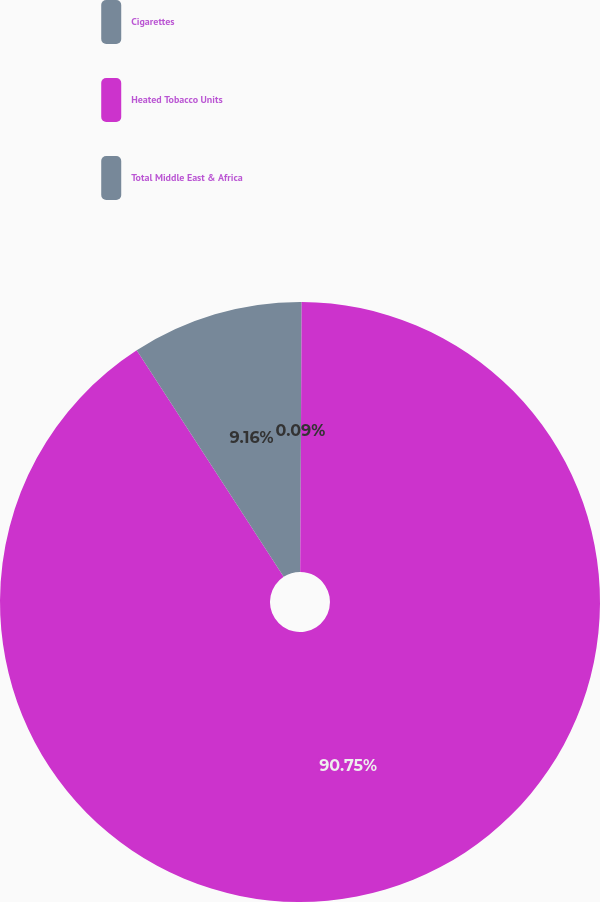Convert chart to OTSL. <chart><loc_0><loc_0><loc_500><loc_500><pie_chart><fcel>Cigarettes<fcel>Heated Tobacco Units<fcel>Total Middle East & Africa<nl><fcel>0.09%<fcel>90.75%<fcel>9.16%<nl></chart> 